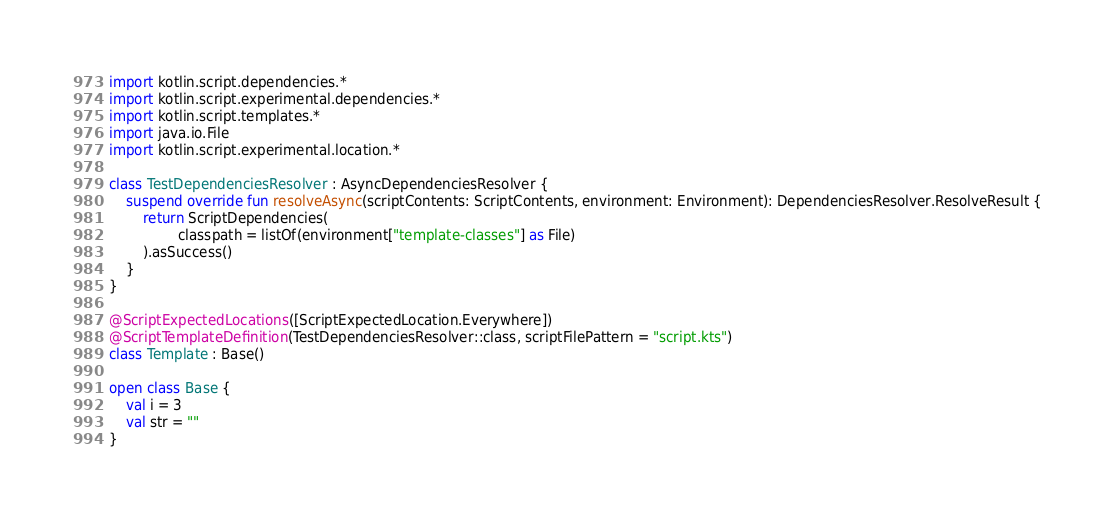Convert code to text. <code><loc_0><loc_0><loc_500><loc_500><_Kotlin_>
import kotlin.script.dependencies.*
import kotlin.script.experimental.dependencies.*
import kotlin.script.templates.*
import java.io.File
import kotlin.script.experimental.location.*

class TestDependenciesResolver : AsyncDependenciesResolver {
    suspend override fun resolveAsync(scriptContents: ScriptContents, environment: Environment): DependenciesResolver.ResolveResult {
        return ScriptDependencies(
                classpath = listOf(environment["template-classes"] as File)
        ).asSuccess()
    }
}

@ScriptExpectedLocations([ScriptExpectedLocation.Everywhere])
@ScriptTemplateDefinition(TestDependenciesResolver::class, scriptFilePattern = "script.kts")
class Template : Base()

open class Base {
    val i = 3
    val str = ""
}</code> 